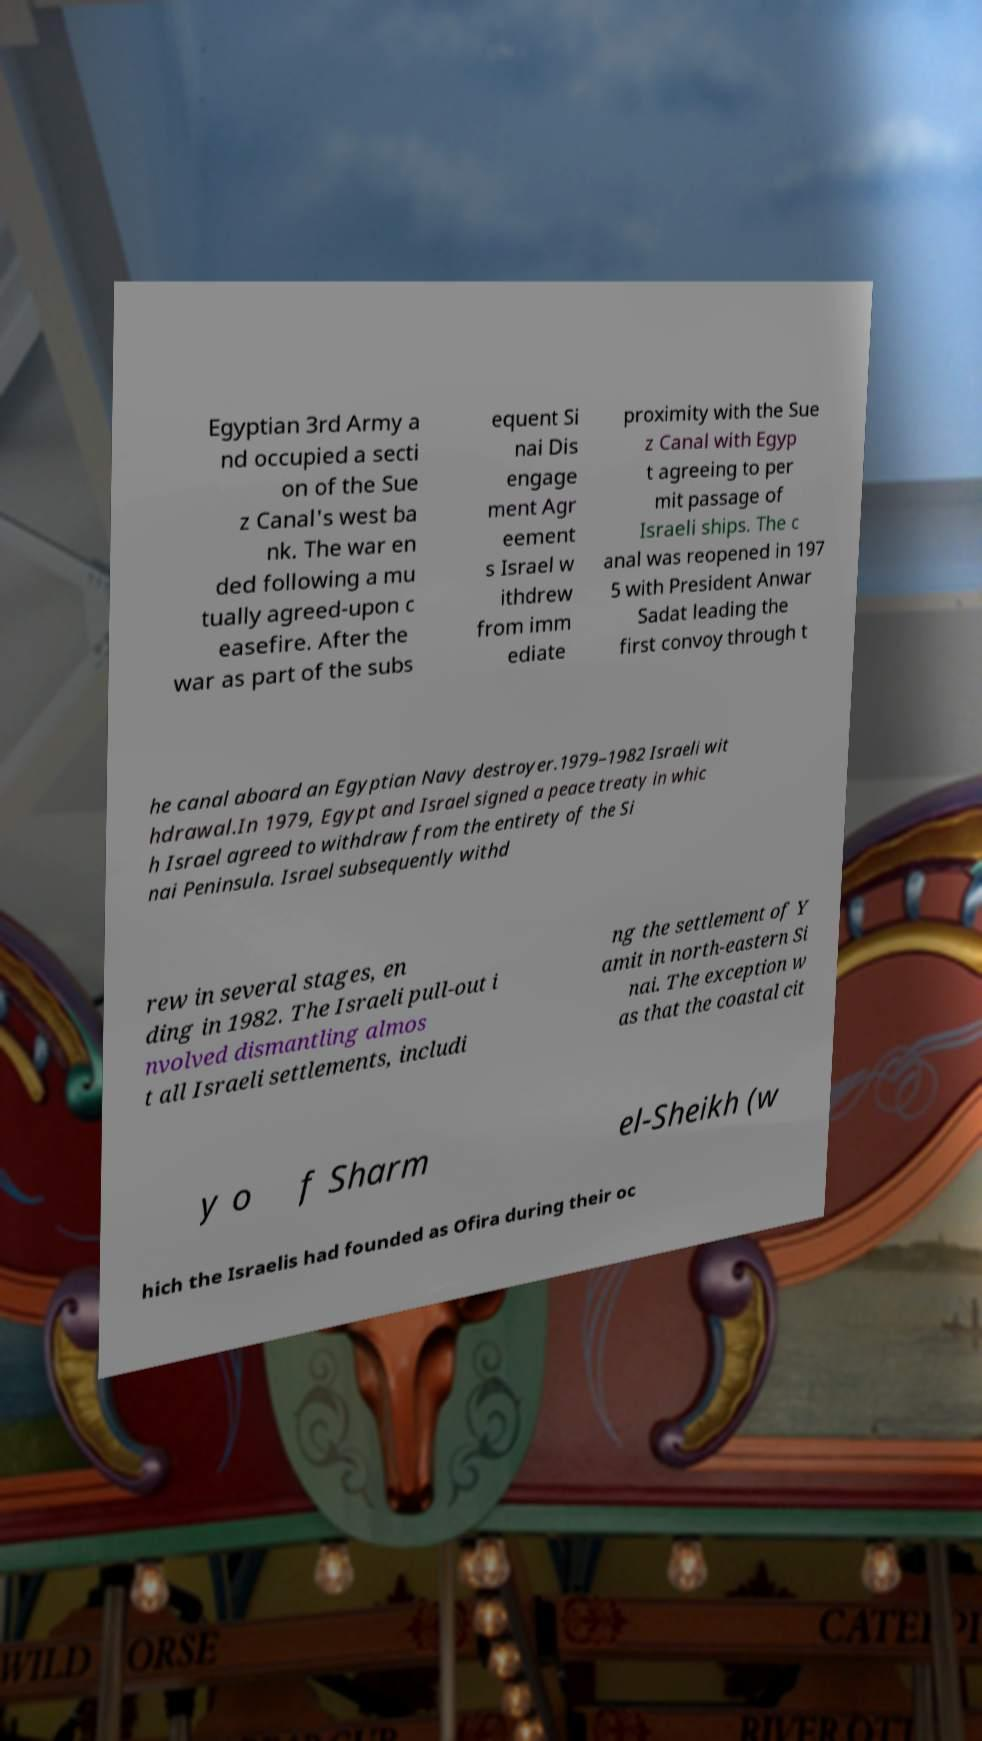Could you extract and type out the text from this image? Egyptian 3rd Army a nd occupied a secti on of the Sue z Canal's west ba nk. The war en ded following a mu tually agreed-upon c easefire. After the war as part of the subs equent Si nai Dis engage ment Agr eement s Israel w ithdrew from imm ediate proximity with the Sue z Canal with Egyp t agreeing to per mit passage of Israeli ships. The c anal was reopened in 197 5 with President Anwar Sadat leading the first convoy through t he canal aboard an Egyptian Navy destroyer.1979–1982 Israeli wit hdrawal.In 1979, Egypt and Israel signed a peace treaty in whic h Israel agreed to withdraw from the entirety of the Si nai Peninsula. Israel subsequently withd rew in several stages, en ding in 1982. The Israeli pull-out i nvolved dismantling almos t all Israeli settlements, includi ng the settlement of Y amit in north-eastern Si nai. The exception w as that the coastal cit y o f Sharm el-Sheikh (w hich the Israelis had founded as Ofira during their oc 